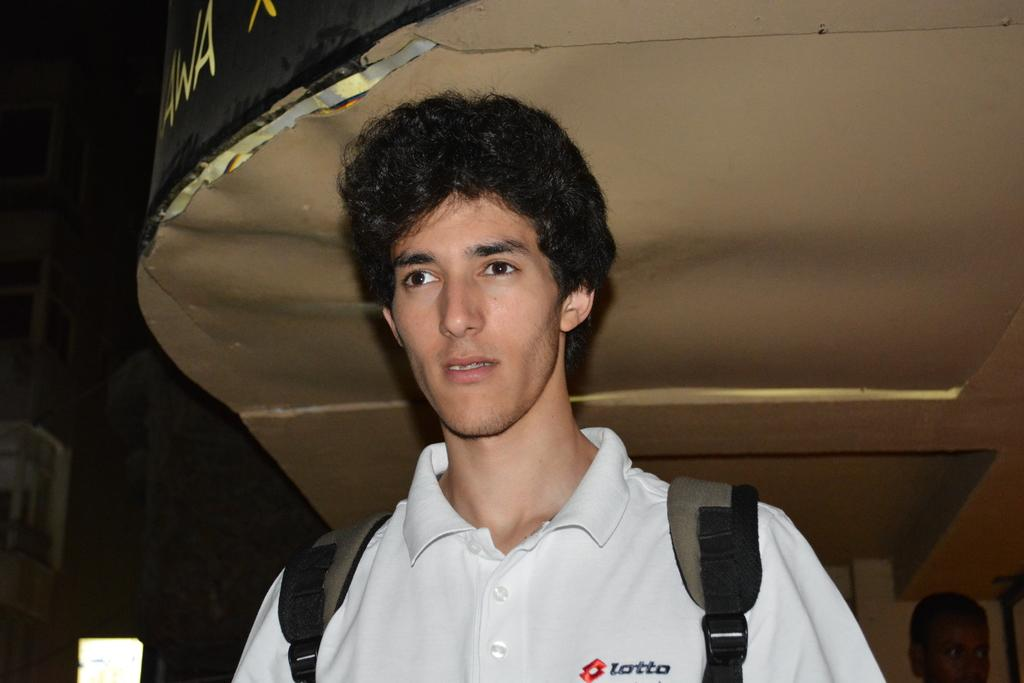What is the main subject of the image? There is a man in the image. What is the man wearing? The man is wearing a white t-shirt. What is the man holding or carrying? The man is carrying a bag. What can be seen in the background of the image? There is a building in the background of the image. Can you describe the person in the bottom right-hand corner of the image? There is a person in the bottom right-hand corner of the image. How would you describe the overall lighting or color of the image? The background of the image is dark. What number is the governor wearing on his boot in the image? There is no governor or boot present in the image. 